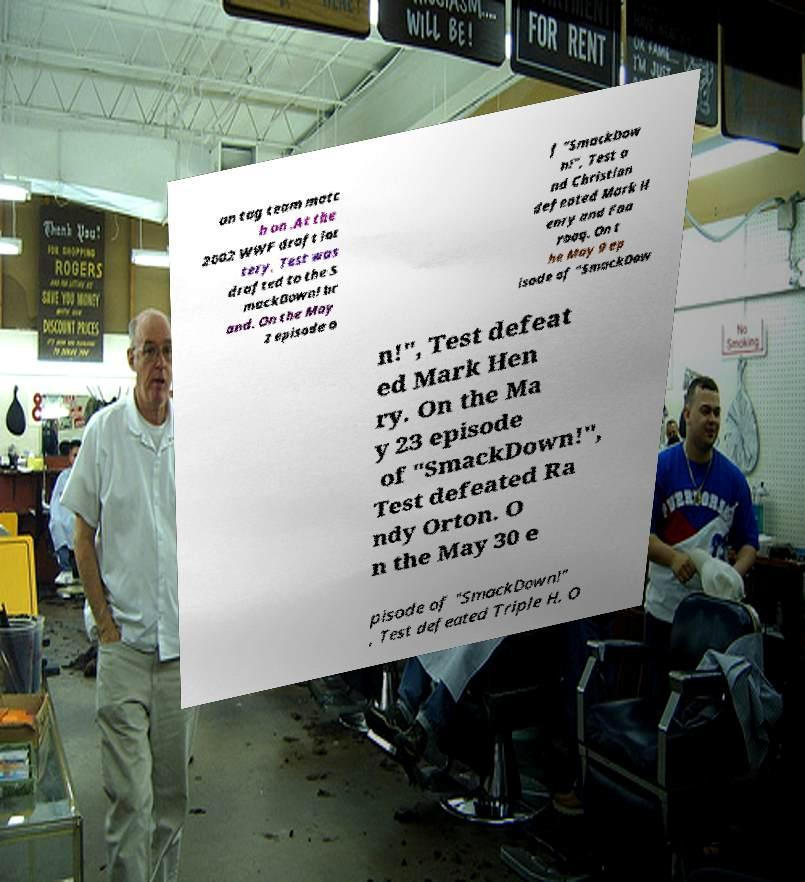Please identify and transcribe the text found in this image. an tag team matc h on .At the 2002 WWF draft lot tery, Test was drafted to the S mackDown! br and. On the May 2 episode o f "SmackDow n!", Test a nd Christian defeated Mark H enry and Faa rooq. On t he May 9 ep isode of "SmackDow n!", Test defeat ed Mark Hen ry. On the Ma y 23 episode of "SmackDown!", Test defeated Ra ndy Orton. O n the May 30 e pisode of "SmackDown!" , Test defeated Triple H. O 